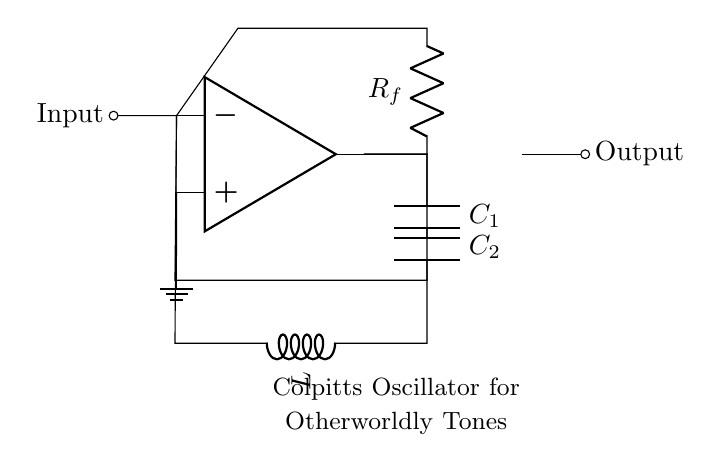What type of oscillator is represented in this circuit? The circuit diagram depicts a Colpitts oscillator, identifiable by the use of capacitors and an inductor connected in a feedback configuration around an operational amplifier.
Answer: Colpitts oscillator How many capacitors are used in the circuit? Observing the circuit diagram, there are two capacitors labeled C1 and C2 connected in the feedback loop of the operational amplifier, which is characteristic of a Colpitts oscillator.
Answer: Two What is the function of the operational amplifier in this circuit? The operational amplifier amplifies the feedback signal, providing the necessary gain for the oscillator to function. Its configuration in the circuit is crucial for generating oscillations.
Answer: Amplification Which component determines the frequency of oscillation in the Colpitts oscillator? The frequency of oscillation is primarily determined by the values of the capacitors (C1, C2) and the inductor (L), as these components define the resonant frequency of the circuit.
Answer: Capacitors and inductor How does the feedback loop influence the behavior of the oscillator? The feedback loop in the circuit provides a portion of the output signal back to the input, creating the condition for oscillation. The correct phase and amplitude of this feedback are essential for sustaining oscillations.
Answer: Sustains oscillation What role does the resistor labeled Rf play in the circuit? The resistor Rf in the circuit is used to set the gain and stability of the oscillator, allowing for control over the oscillation amplitude while also preventing excessive output.
Answer: Gain and stability control 